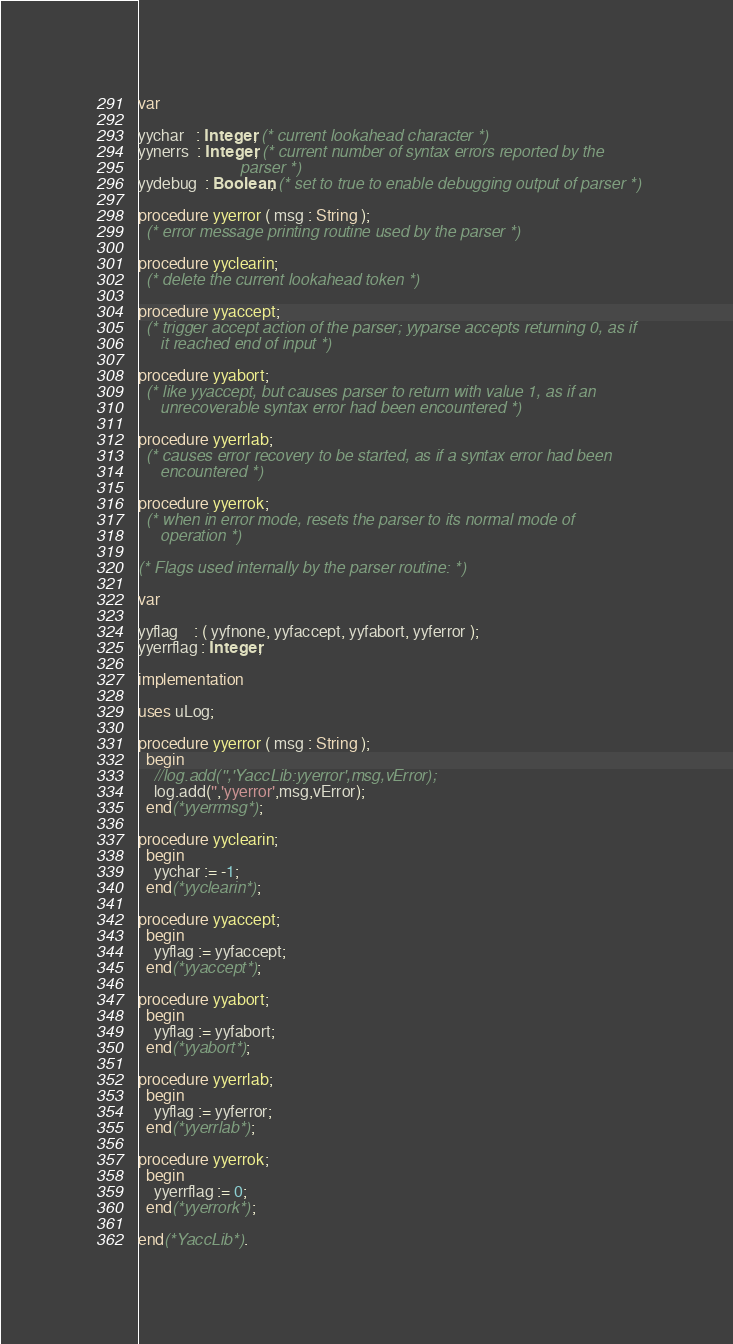<code> <loc_0><loc_0><loc_500><loc_500><_Pascal_>
var

yychar   : Integer; (* current lookahead character *)
yynerrs  : Integer; (* current number of syntax errors reported by the
                       parser *)
yydebug  : Boolean; (* set to true to enable debugging output of parser *)

procedure yyerror ( msg : String );
  (* error message printing routine used by the parser *)

procedure yyclearin;
  (* delete the current lookahead token *)

procedure yyaccept;
  (* trigger accept action of the parser; yyparse accepts returning 0, as if
     it reached end of input *)

procedure yyabort;
  (* like yyaccept, but causes parser to return with value 1, as if an
     unrecoverable syntax error had been encountered *)

procedure yyerrlab;
  (* causes error recovery to be started, as if a syntax error had been
     encountered *)

procedure yyerrok;
  (* when in error mode, resets the parser to its normal mode of
     operation *)

(* Flags used internally by the parser routine: *)

var

yyflag    : ( yyfnone, yyfaccept, yyfabort, yyferror );
yyerrflag : Integer;

implementation

uses uLog;

procedure yyerror ( msg : String );
  begin
    //log.add('','YaccLib:yyerror',msg,vError);
    log.add('','yyerror',msg,vError);
  end(*yyerrmsg*);

procedure yyclearin;
  begin
    yychar := -1;
  end(*yyclearin*);

procedure yyaccept;
  begin
    yyflag := yyfaccept;
  end(*yyaccept*);

procedure yyabort;
  begin
    yyflag := yyfabort;
  end(*yyabort*);

procedure yyerrlab;
  begin
    yyflag := yyferror;
  end(*yyerrlab*);

procedure yyerrok;
  begin
    yyerrflag := 0;
  end(*yyerrork*);

end(*YaccLib*).
</code> 